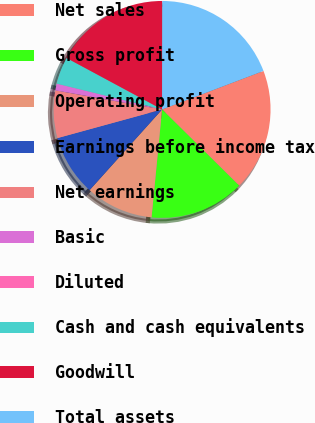Convert chart to OTSL. <chart><loc_0><loc_0><loc_500><loc_500><pie_chart><fcel>Net sales<fcel>Gross profit<fcel>Operating profit<fcel>Earnings before income tax<fcel>Net earnings<fcel>Basic<fcel>Diluted<fcel>Cash and cash equivalents<fcel>Goodwill<fcel>Total assets<nl><fcel>18.18%<fcel>14.14%<fcel>10.1%<fcel>9.09%<fcel>7.07%<fcel>1.01%<fcel>0.0%<fcel>4.04%<fcel>17.17%<fcel>19.19%<nl></chart> 